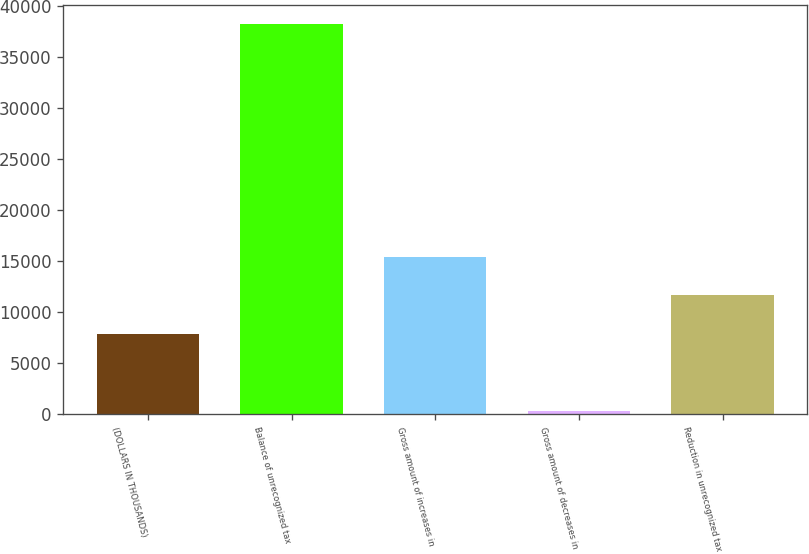Convert chart to OTSL. <chart><loc_0><loc_0><loc_500><loc_500><bar_chart><fcel>(DOLLARS IN THOUSANDS)<fcel>Balance of unrecognized tax<fcel>Gross amount of increases in<fcel>Gross amount of decreases in<fcel>Reduction in unrecognized tax<nl><fcel>7846.8<fcel>38162<fcel>15425.6<fcel>268<fcel>11636.2<nl></chart> 